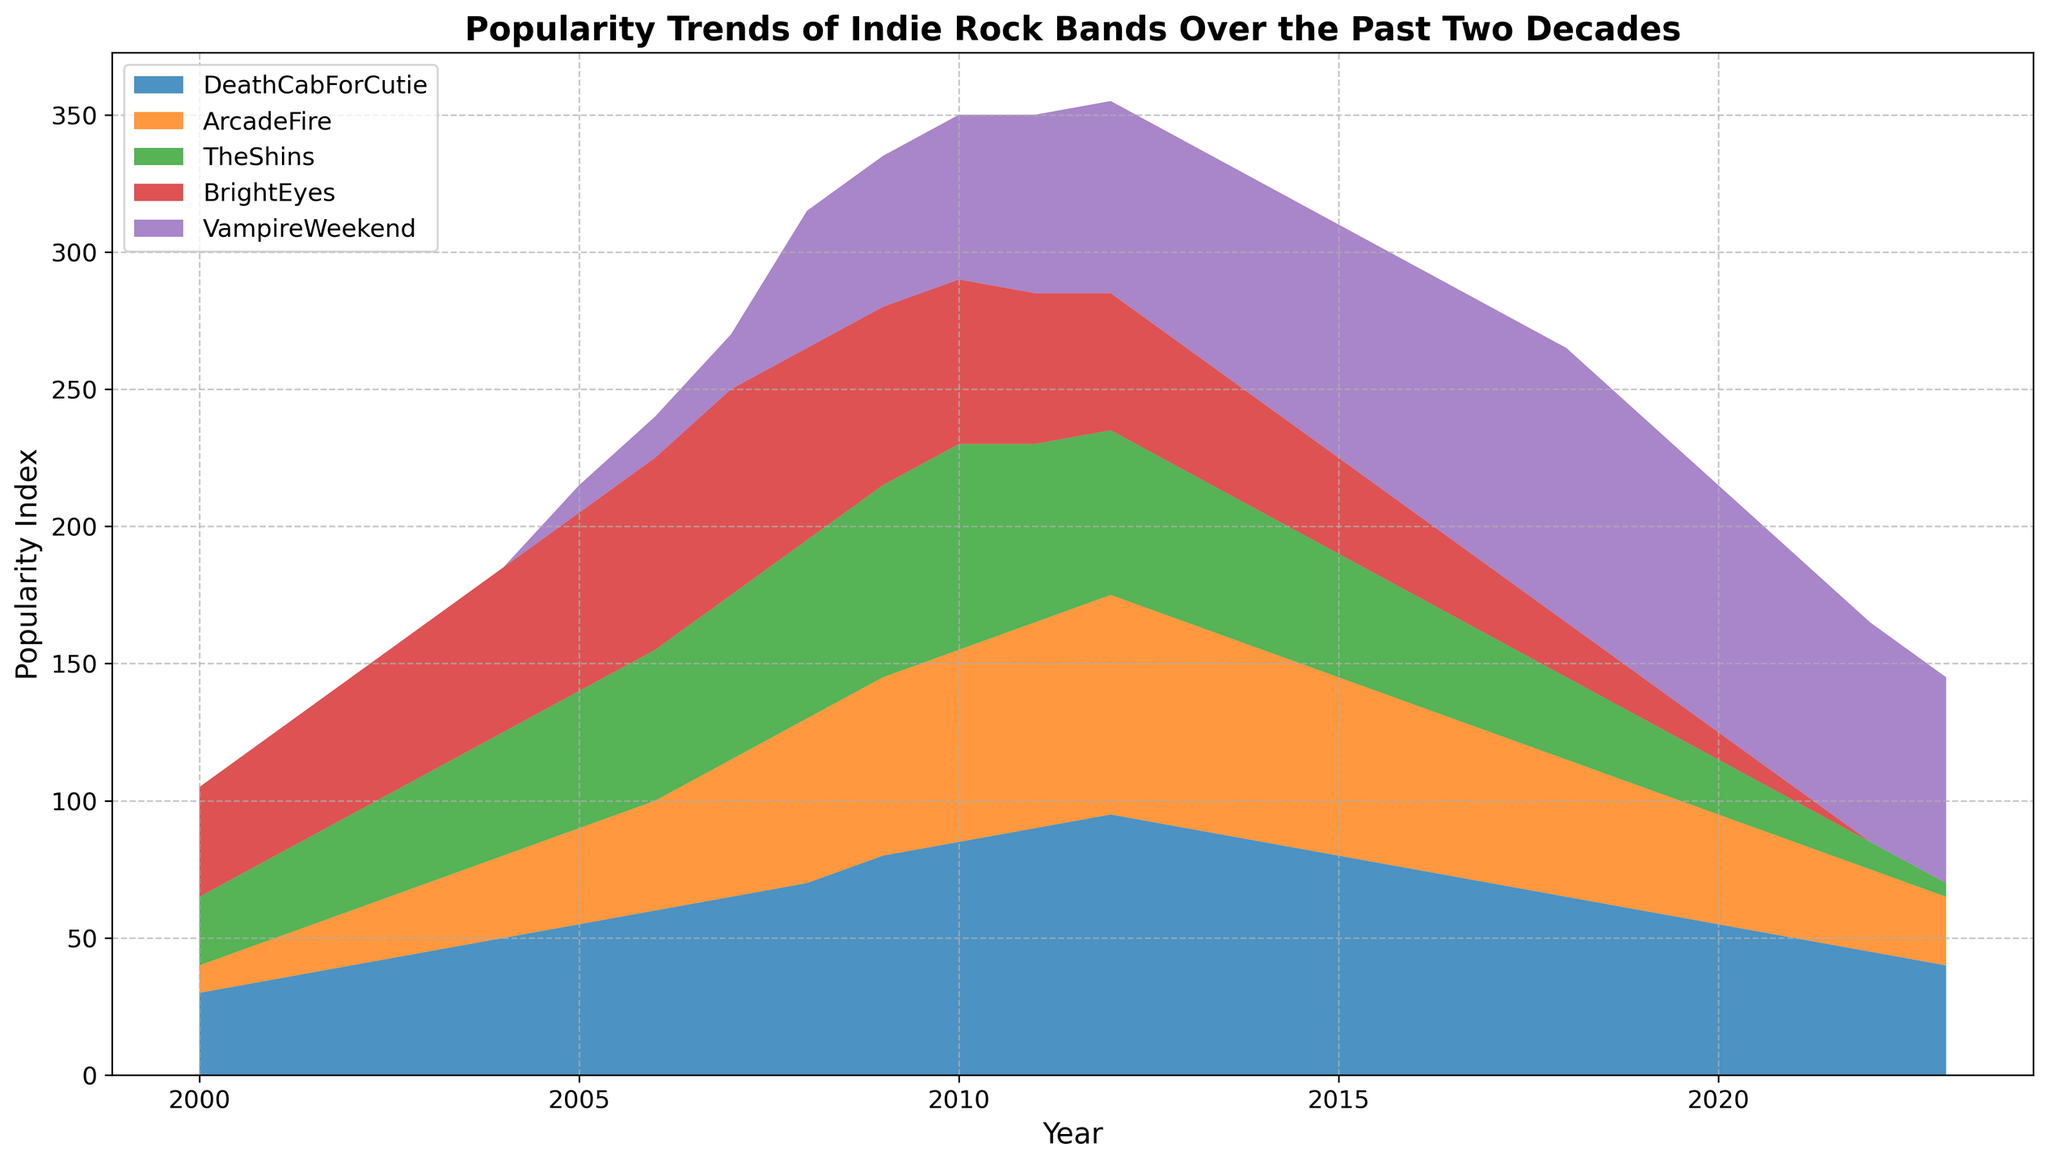What's the peak popularity index for Death Cab for Cutie, and in what year was it achieved? The peak popularity index for Death Cab for Cutie on the figure is the highest point in the area representing their popularity. By observing the highest point, it's 95 in the year 2012.
Answer: 95 in 2012 Which band had the highest popularity index in 2018 and what was the value? In 2018, the highest area segment belongs to Vampire Weekend at the top of the stack, indicating they had the highest popularity. The value for Vampire Weekend in 2018 is 100.
Answer: Vampire Weekend with 100 Between 2007 and 2010, which two bands had the most significant increase in popularity index and by how much did each increase? To determine the significant increase, compare the popularity indices from 2007 to 2010 for each band. Death Cab for Cutie increased from 65 to 85 (20 points), and Arcade Fire increased from 50 to 70 (20 points), making them the bands with the most significant increase during this period.
Answer: Death Cab for Cutie: 20, Arcade Fire: 20 During which year did Death Cab for Cutie and The Shins have equal popularity, and what was the value? To find this, look for the year where the heights of the segments for Death Cab for Cutie and The Shins are the same. This occurs in the year 2023, where both bands have a popularity index of 40 for Death Cab for Cutie and 5 for The Shins individually.
Answer: Never Which band's popularity declined most sharply between 2015 and 2022? Comparing the decline for each band from 2015 to 2022, Death Cab for Cutie went from 80 to 45, Arcade Fire from 65 to 30, The Shins from 45 to 10, Bright Eyes from 35 to 0, and Vampire Weekend from 85 to 80. Bright Eyes had the sharpest decline, losing 100% of their popularity from 35 to 0.
Answer: Bright Eyes In what year did Vampire Weekend become more popular than The Shins? Find the first year where Vampire Weekend's segment height surpasses that of The Shins. This happened in 2008, where Vampire Weekend's popularity index was 50, while The Shins had a popularity index of 65.
Answer: 2008 How much did the popularity index of Bright Eyes decrease from its peak to its lowest in the chart? Determine the peak value for Bright Eyes, which is 75 in 2007, and the lowest value, which is 0 starting from 2021. The decrease is 75 - 0 = 75.
Answer: 75 